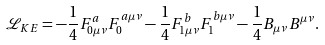Convert formula to latex. <formula><loc_0><loc_0><loc_500><loc_500>\mathcal { L } _ { K E } = - \frac { 1 } { 4 } F ^ { a } _ { 0 \mu \nu } F _ { 0 } ^ { a \mu \nu } - \frac { 1 } { 4 } F ^ { b } _ { 1 \mu \nu } F _ { 1 } ^ { b \mu \nu } - \frac { 1 } { 4 } B _ { \mu \nu } B ^ { \mu \nu } .</formula> 